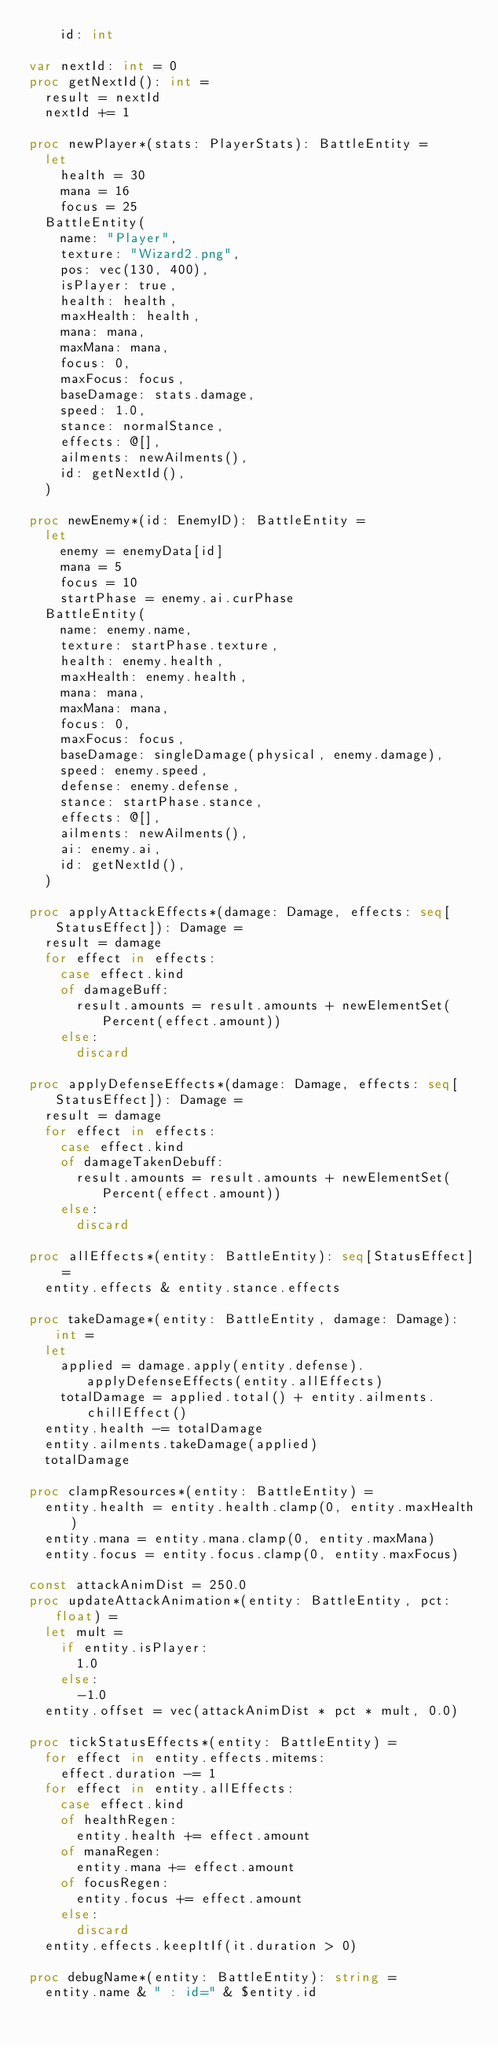Convert code to text. <code><loc_0><loc_0><loc_500><loc_500><_Nim_>    id: int

var nextId: int = 0
proc getNextId(): int =
  result = nextId
  nextId += 1

proc newPlayer*(stats: PlayerStats): BattleEntity =
  let
    health = 30
    mana = 16
    focus = 25
  BattleEntity(
    name: "Player",
    texture: "Wizard2.png",
    pos: vec(130, 400),
    isPlayer: true,
    health: health,
    maxHealth: health,
    mana: mana,
    maxMana: mana,
    focus: 0,
    maxFocus: focus,
    baseDamage: stats.damage,
    speed: 1.0,
    stance: normalStance,
    effects: @[],
    ailments: newAilments(),
    id: getNextId(),
  )

proc newEnemy*(id: EnemyID): BattleEntity =
  let
    enemy = enemyData[id]
    mana = 5
    focus = 10
    startPhase = enemy.ai.curPhase
  BattleEntity(
    name: enemy.name,
    texture: startPhase.texture,
    health: enemy.health,
    maxHealth: enemy.health,
    mana: mana,
    maxMana: mana,
    focus: 0,
    maxFocus: focus,
    baseDamage: singleDamage(physical, enemy.damage),
    speed: enemy.speed,
    defense: enemy.defense,
    stance: startPhase.stance,
    effects: @[],
    ailments: newAilments(),
    ai: enemy.ai,
    id: getNextId(),
  )

proc applyAttackEffects*(damage: Damage, effects: seq[StatusEffect]): Damage =
  result = damage
  for effect in effects:
    case effect.kind
    of damageBuff:
      result.amounts = result.amounts + newElementSet(Percent(effect.amount))
    else:
      discard

proc applyDefenseEffects*(damage: Damage, effects: seq[StatusEffect]): Damage =
  result = damage
  for effect in effects:
    case effect.kind
    of damageTakenDebuff:
      result.amounts = result.amounts + newElementSet(Percent(effect.amount))
    else:
      discard

proc allEffects*(entity: BattleEntity): seq[StatusEffect] =
  entity.effects & entity.stance.effects

proc takeDamage*(entity: BattleEntity, damage: Damage): int =
  let
    applied = damage.apply(entity.defense).applyDefenseEffects(entity.allEffects)
    totalDamage = applied.total() + entity.ailments.chillEffect()
  entity.health -= totalDamage
  entity.ailments.takeDamage(applied)
  totalDamage

proc clampResources*(entity: BattleEntity) =
  entity.health = entity.health.clamp(0, entity.maxHealth)
  entity.mana = entity.mana.clamp(0, entity.maxMana)
  entity.focus = entity.focus.clamp(0, entity.maxFocus)

const attackAnimDist = 250.0
proc updateAttackAnimation*(entity: BattleEntity, pct: float) =
  let mult =
    if entity.isPlayer:
      1.0
    else:
      -1.0
  entity.offset = vec(attackAnimDist * pct * mult, 0.0)

proc tickStatusEffects*(entity: BattleEntity) =
  for effect in entity.effects.mitems:
    effect.duration -= 1
  for effect in entity.allEffects:
    case effect.kind
    of healthRegen:
      entity.health += effect.amount
    of manaRegen:
      entity.mana += effect.amount
    of focusRegen:
      entity.focus += effect.amount
    else:
      discard
  entity.effects.keepItIf(it.duration > 0)

proc debugName*(entity: BattleEntity): string =
  entity.name & " : id=" & $entity.id
</code> 